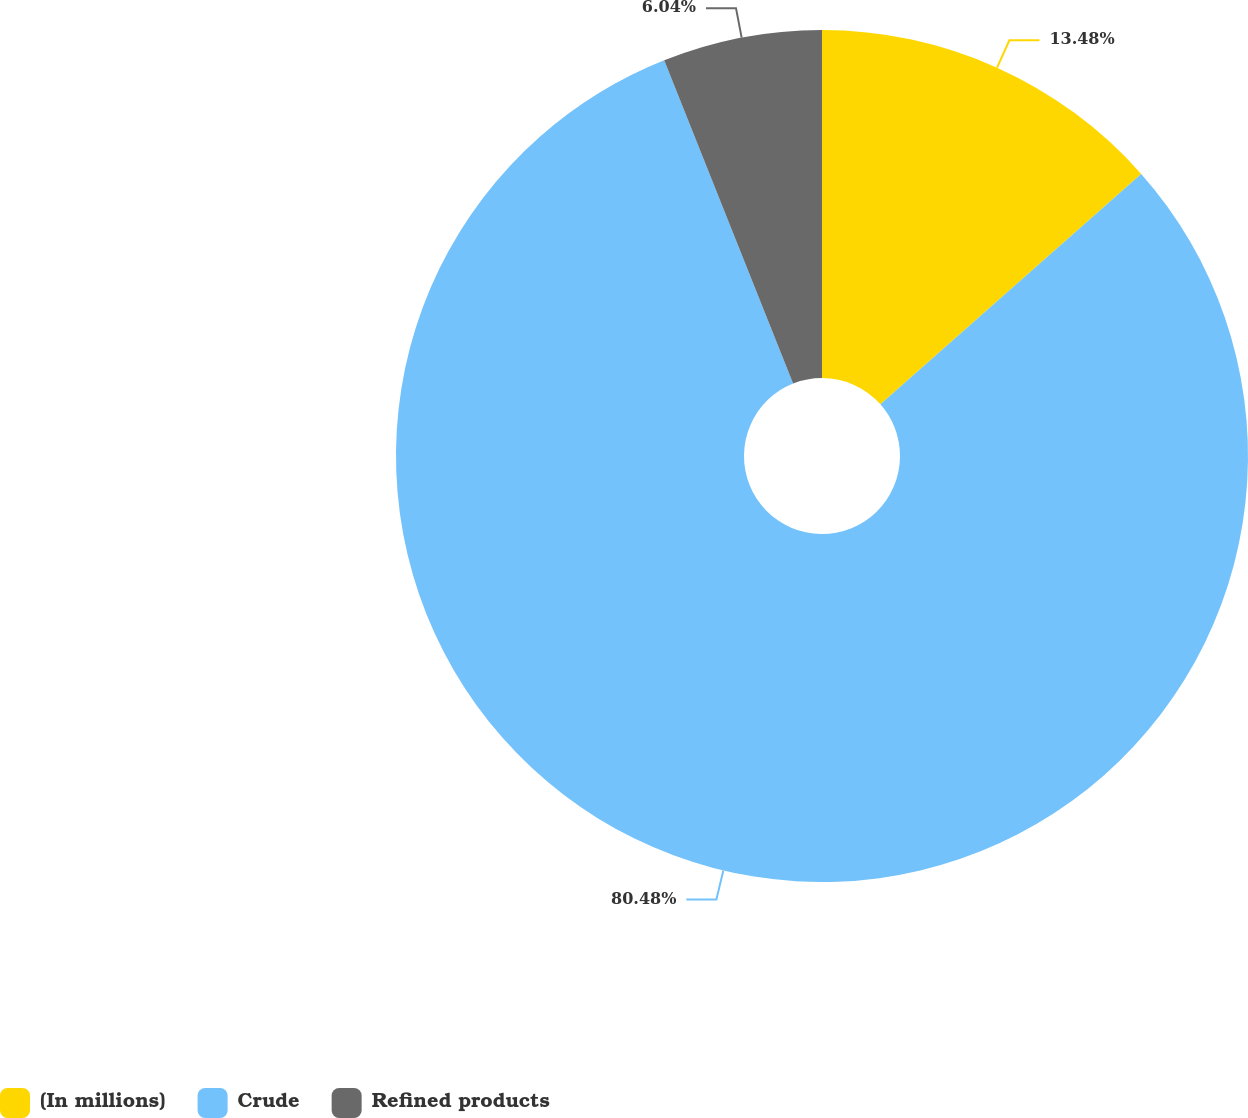Convert chart to OTSL. <chart><loc_0><loc_0><loc_500><loc_500><pie_chart><fcel>(In millions)<fcel>Crude<fcel>Refined products<nl><fcel>13.48%<fcel>80.48%<fcel>6.04%<nl></chart> 